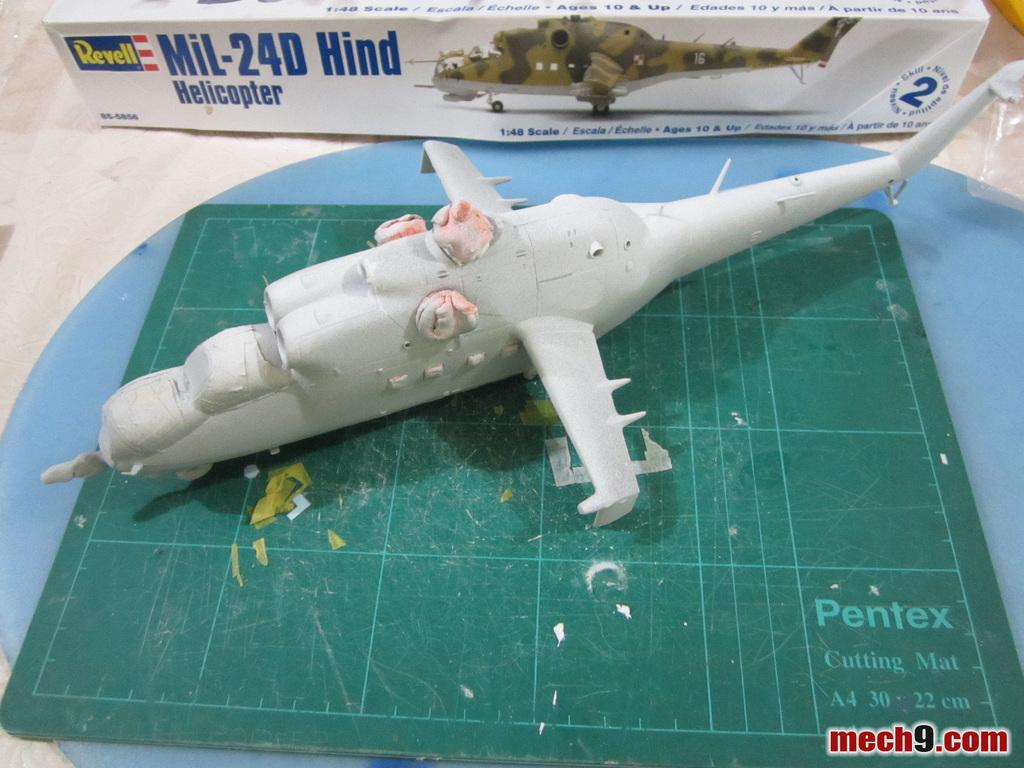Provide a one-sentence caption for the provided image. A Revell model helicopter is being constructed on a Pentex brand cutting mat. 